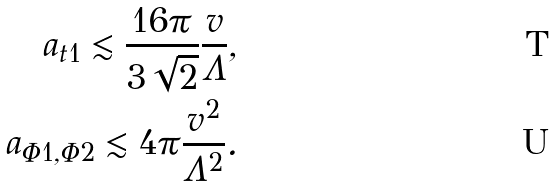Convert formula to latex. <formula><loc_0><loc_0><loc_500><loc_500>a _ { t 1 } \lesssim \frac { 1 6 \pi } { 3 \sqrt { 2 } } \frac { v } { \Lambda } , \\ a _ { \Phi 1 , \Phi 2 } \lesssim 4 \pi \frac { v ^ { 2 } } { \Lambda ^ { 2 } } .</formula> 